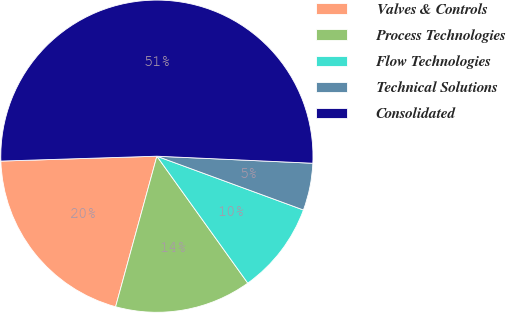<chart> <loc_0><loc_0><loc_500><loc_500><pie_chart><fcel>Valves & Controls<fcel>Process Technologies<fcel>Flow Technologies<fcel>Technical Solutions<fcel>Consolidated<nl><fcel>20.24%<fcel>14.15%<fcel>9.51%<fcel>4.88%<fcel>51.21%<nl></chart> 